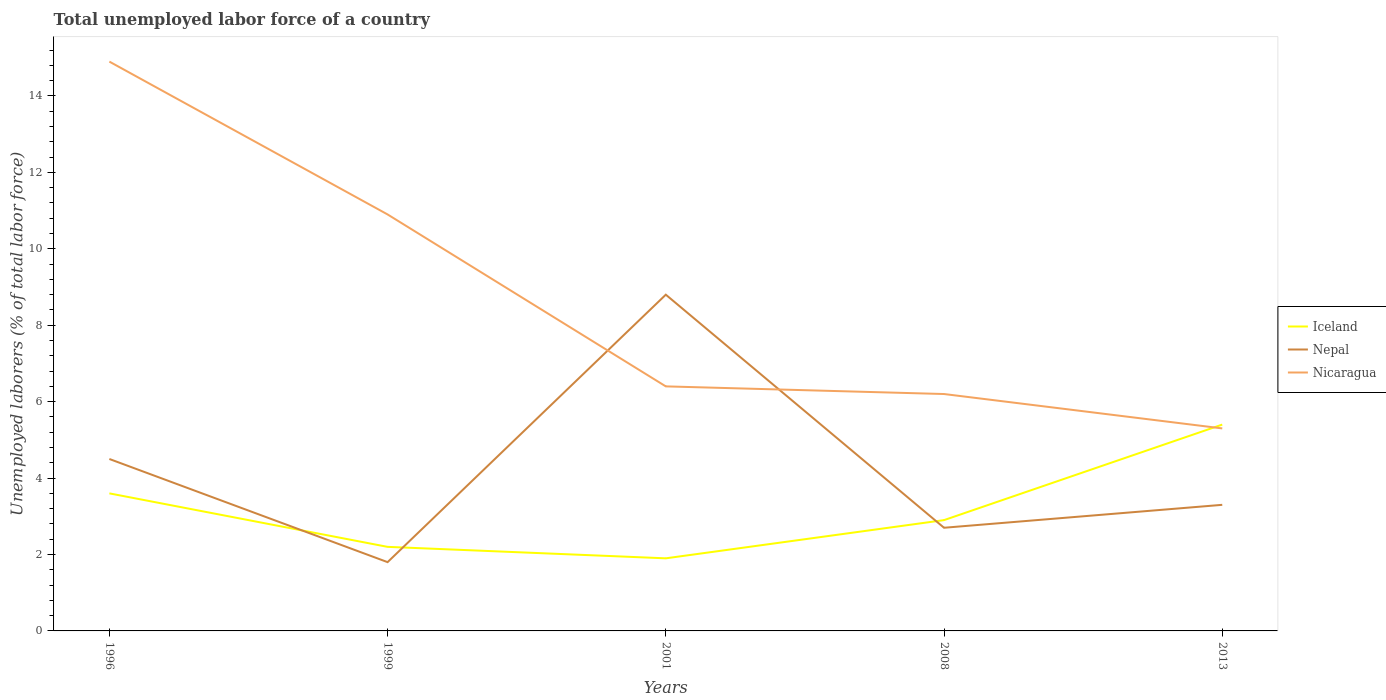How many different coloured lines are there?
Ensure brevity in your answer.  3. Does the line corresponding to Iceland intersect with the line corresponding to Nepal?
Keep it short and to the point. Yes. Is the number of lines equal to the number of legend labels?
Your answer should be compact. Yes. Across all years, what is the maximum total unemployed labor force in Iceland?
Ensure brevity in your answer.  1.9. In which year was the total unemployed labor force in Nicaragua maximum?
Your answer should be very brief. 2013. What is the total total unemployed labor force in Nicaragua in the graph?
Offer a very short reply. 1.1. What is the difference between the highest and the second highest total unemployed labor force in Nicaragua?
Ensure brevity in your answer.  9.6. Is the total unemployed labor force in Nepal strictly greater than the total unemployed labor force in Iceland over the years?
Offer a terse response. No. What is the difference between two consecutive major ticks on the Y-axis?
Your answer should be compact. 2. Where does the legend appear in the graph?
Keep it short and to the point. Center right. What is the title of the graph?
Ensure brevity in your answer.  Total unemployed labor force of a country. What is the label or title of the X-axis?
Your response must be concise. Years. What is the label or title of the Y-axis?
Keep it short and to the point. Unemployed laborers (% of total labor force). What is the Unemployed laborers (% of total labor force) in Iceland in 1996?
Provide a succinct answer. 3.6. What is the Unemployed laborers (% of total labor force) in Nepal in 1996?
Your answer should be compact. 4.5. What is the Unemployed laborers (% of total labor force) of Nicaragua in 1996?
Make the answer very short. 14.9. What is the Unemployed laborers (% of total labor force) in Iceland in 1999?
Your answer should be compact. 2.2. What is the Unemployed laborers (% of total labor force) of Nepal in 1999?
Provide a short and direct response. 1.8. What is the Unemployed laborers (% of total labor force) of Nicaragua in 1999?
Keep it short and to the point. 10.9. What is the Unemployed laborers (% of total labor force) of Iceland in 2001?
Keep it short and to the point. 1.9. What is the Unemployed laborers (% of total labor force) of Nepal in 2001?
Make the answer very short. 8.8. What is the Unemployed laborers (% of total labor force) of Nicaragua in 2001?
Your response must be concise. 6.4. What is the Unemployed laborers (% of total labor force) of Iceland in 2008?
Your response must be concise. 2.9. What is the Unemployed laborers (% of total labor force) in Nepal in 2008?
Make the answer very short. 2.7. What is the Unemployed laborers (% of total labor force) of Nicaragua in 2008?
Your answer should be compact. 6.2. What is the Unemployed laborers (% of total labor force) in Iceland in 2013?
Provide a succinct answer. 5.4. What is the Unemployed laborers (% of total labor force) of Nepal in 2013?
Your response must be concise. 3.3. What is the Unemployed laborers (% of total labor force) of Nicaragua in 2013?
Your answer should be very brief. 5.3. Across all years, what is the maximum Unemployed laborers (% of total labor force) of Iceland?
Provide a succinct answer. 5.4. Across all years, what is the maximum Unemployed laborers (% of total labor force) in Nepal?
Offer a terse response. 8.8. Across all years, what is the maximum Unemployed laborers (% of total labor force) in Nicaragua?
Keep it short and to the point. 14.9. Across all years, what is the minimum Unemployed laborers (% of total labor force) of Iceland?
Provide a short and direct response. 1.9. Across all years, what is the minimum Unemployed laborers (% of total labor force) of Nepal?
Ensure brevity in your answer.  1.8. Across all years, what is the minimum Unemployed laborers (% of total labor force) in Nicaragua?
Provide a succinct answer. 5.3. What is the total Unemployed laborers (% of total labor force) of Nepal in the graph?
Offer a terse response. 21.1. What is the total Unemployed laborers (% of total labor force) in Nicaragua in the graph?
Offer a very short reply. 43.7. What is the difference between the Unemployed laborers (% of total labor force) in Iceland in 1996 and that in 1999?
Your answer should be very brief. 1.4. What is the difference between the Unemployed laborers (% of total labor force) of Nepal in 1996 and that in 1999?
Your answer should be very brief. 2.7. What is the difference between the Unemployed laborers (% of total labor force) in Iceland in 1996 and that in 2001?
Provide a short and direct response. 1.7. What is the difference between the Unemployed laborers (% of total labor force) of Nepal in 1996 and that in 2001?
Give a very brief answer. -4.3. What is the difference between the Unemployed laborers (% of total labor force) in Nicaragua in 1996 and that in 2001?
Your response must be concise. 8.5. What is the difference between the Unemployed laborers (% of total labor force) of Iceland in 1996 and that in 2008?
Your answer should be compact. 0.7. What is the difference between the Unemployed laborers (% of total labor force) in Iceland in 1999 and that in 2001?
Your answer should be very brief. 0.3. What is the difference between the Unemployed laborers (% of total labor force) in Nepal in 1999 and that in 2001?
Offer a terse response. -7. What is the difference between the Unemployed laborers (% of total labor force) in Iceland in 1999 and that in 2008?
Offer a terse response. -0.7. What is the difference between the Unemployed laborers (% of total labor force) in Iceland in 1999 and that in 2013?
Make the answer very short. -3.2. What is the difference between the Unemployed laborers (% of total labor force) in Nepal in 1999 and that in 2013?
Ensure brevity in your answer.  -1.5. What is the difference between the Unemployed laborers (% of total labor force) of Nicaragua in 1999 and that in 2013?
Give a very brief answer. 5.6. What is the difference between the Unemployed laborers (% of total labor force) of Nepal in 2001 and that in 2008?
Your answer should be compact. 6.1. What is the difference between the Unemployed laborers (% of total labor force) in Nicaragua in 2001 and that in 2008?
Give a very brief answer. 0.2. What is the difference between the Unemployed laborers (% of total labor force) of Iceland in 2001 and that in 2013?
Your answer should be compact. -3.5. What is the difference between the Unemployed laborers (% of total labor force) in Iceland in 2008 and that in 2013?
Your response must be concise. -2.5. What is the difference between the Unemployed laborers (% of total labor force) in Iceland in 1996 and the Unemployed laborers (% of total labor force) in Nicaragua in 1999?
Make the answer very short. -7.3. What is the difference between the Unemployed laborers (% of total labor force) in Nepal in 1996 and the Unemployed laborers (% of total labor force) in Nicaragua in 1999?
Make the answer very short. -6.4. What is the difference between the Unemployed laborers (% of total labor force) of Iceland in 1996 and the Unemployed laborers (% of total labor force) of Nepal in 2001?
Ensure brevity in your answer.  -5.2. What is the difference between the Unemployed laborers (% of total labor force) in Nepal in 1996 and the Unemployed laborers (% of total labor force) in Nicaragua in 2001?
Offer a terse response. -1.9. What is the difference between the Unemployed laborers (% of total labor force) of Iceland in 1996 and the Unemployed laborers (% of total labor force) of Nepal in 2013?
Offer a very short reply. 0.3. What is the difference between the Unemployed laborers (% of total labor force) in Nepal in 1999 and the Unemployed laborers (% of total labor force) in Nicaragua in 2001?
Provide a succinct answer. -4.6. What is the difference between the Unemployed laborers (% of total labor force) in Iceland in 1999 and the Unemployed laborers (% of total labor force) in Nepal in 2013?
Offer a very short reply. -1.1. What is the difference between the Unemployed laborers (% of total labor force) in Nepal in 1999 and the Unemployed laborers (% of total labor force) in Nicaragua in 2013?
Make the answer very short. -3.5. What is the difference between the Unemployed laborers (% of total labor force) of Iceland in 2001 and the Unemployed laborers (% of total labor force) of Nepal in 2008?
Ensure brevity in your answer.  -0.8. What is the difference between the Unemployed laborers (% of total labor force) of Iceland in 2001 and the Unemployed laborers (% of total labor force) of Nepal in 2013?
Your response must be concise. -1.4. What is the difference between the Unemployed laborers (% of total labor force) of Iceland in 2001 and the Unemployed laborers (% of total labor force) of Nicaragua in 2013?
Make the answer very short. -3.4. What is the difference between the Unemployed laborers (% of total labor force) in Iceland in 2008 and the Unemployed laborers (% of total labor force) in Nicaragua in 2013?
Provide a succinct answer. -2.4. What is the average Unemployed laborers (% of total labor force) of Nepal per year?
Provide a succinct answer. 4.22. What is the average Unemployed laborers (% of total labor force) in Nicaragua per year?
Keep it short and to the point. 8.74. In the year 1996, what is the difference between the Unemployed laborers (% of total labor force) of Iceland and Unemployed laborers (% of total labor force) of Nepal?
Provide a succinct answer. -0.9. In the year 1996, what is the difference between the Unemployed laborers (% of total labor force) of Nepal and Unemployed laborers (% of total labor force) of Nicaragua?
Keep it short and to the point. -10.4. In the year 1999, what is the difference between the Unemployed laborers (% of total labor force) in Nepal and Unemployed laborers (% of total labor force) in Nicaragua?
Give a very brief answer. -9.1. In the year 2001, what is the difference between the Unemployed laborers (% of total labor force) in Iceland and Unemployed laborers (% of total labor force) in Nepal?
Ensure brevity in your answer.  -6.9. In the year 2001, what is the difference between the Unemployed laborers (% of total labor force) in Iceland and Unemployed laborers (% of total labor force) in Nicaragua?
Offer a very short reply. -4.5. In the year 2001, what is the difference between the Unemployed laborers (% of total labor force) in Nepal and Unemployed laborers (% of total labor force) in Nicaragua?
Give a very brief answer. 2.4. In the year 2008, what is the difference between the Unemployed laborers (% of total labor force) in Iceland and Unemployed laborers (% of total labor force) in Nicaragua?
Make the answer very short. -3.3. In the year 2013, what is the difference between the Unemployed laborers (% of total labor force) of Iceland and Unemployed laborers (% of total labor force) of Nicaragua?
Give a very brief answer. 0.1. In the year 2013, what is the difference between the Unemployed laborers (% of total labor force) in Nepal and Unemployed laborers (% of total labor force) in Nicaragua?
Provide a succinct answer. -2. What is the ratio of the Unemployed laborers (% of total labor force) in Iceland in 1996 to that in 1999?
Provide a succinct answer. 1.64. What is the ratio of the Unemployed laborers (% of total labor force) in Nepal in 1996 to that in 1999?
Give a very brief answer. 2.5. What is the ratio of the Unemployed laborers (% of total labor force) in Nicaragua in 1996 to that in 1999?
Your response must be concise. 1.37. What is the ratio of the Unemployed laborers (% of total labor force) of Iceland in 1996 to that in 2001?
Your response must be concise. 1.89. What is the ratio of the Unemployed laborers (% of total labor force) of Nepal in 1996 to that in 2001?
Offer a terse response. 0.51. What is the ratio of the Unemployed laborers (% of total labor force) in Nicaragua in 1996 to that in 2001?
Your response must be concise. 2.33. What is the ratio of the Unemployed laborers (% of total labor force) in Iceland in 1996 to that in 2008?
Keep it short and to the point. 1.24. What is the ratio of the Unemployed laborers (% of total labor force) in Nicaragua in 1996 to that in 2008?
Keep it short and to the point. 2.4. What is the ratio of the Unemployed laborers (% of total labor force) of Nepal in 1996 to that in 2013?
Ensure brevity in your answer.  1.36. What is the ratio of the Unemployed laborers (% of total labor force) of Nicaragua in 1996 to that in 2013?
Give a very brief answer. 2.81. What is the ratio of the Unemployed laborers (% of total labor force) of Iceland in 1999 to that in 2001?
Make the answer very short. 1.16. What is the ratio of the Unemployed laborers (% of total labor force) of Nepal in 1999 to that in 2001?
Offer a terse response. 0.2. What is the ratio of the Unemployed laborers (% of total labor force) of Nicaragua in 1999 to that in 2001?
Ensure brevity in your answer.  1.7. What is the ratio of the Unemployed laborers (% of total labor force) in Iceland in 1999 to that in 2008?
Offer a very short reply. 0.76. What is the ratio of the Unemployed laborers (% of total labor force) of Nepal in 1999 to that in 2008?
Offer a very short reply. 0.67. What is the ratio of the Unemployed laborers (% of total labor force) in Nicaragua in 1999 to that in 2008?
Your response must be concise. 1.76. What is the ratio of the Unemployed laborers (% of total labor force) in Iceland in 1999 to that in 2013?
Your answer should be very brief. 0.41. What is the ratio of the Unemployed laborers (% of total labor force) of Nepal in 1999 to that in 2013?
Provide a succinct answer. 0.55. What is the ratio of the Unemployed laborers (% of total labor force) of Nicaragua in 1999 to that in 2013?
Give a very brief answer. 2.06. What is the ratio of the Unemployed laborers (% of total labor force) of Iceland in 2001 to that in 2008?
Offer a terse response. 0.66. What is the ratio of the Unemployed laborers (% of total labor force) of Nepal in 2001 to that in 2008?
Give a very brief answer. 3.26. What is the ratio of the Unemployed laborers (% of total labor force) of Nicaragua in 2001 to that in 2008?
Your answer should be compact. 1.03. What is the ratio of the Unemployed laborers (% of total labor force) in Iceland in 2001 to that in 2013?
Your answer should be very brief. 0.35. What is the ratio of the Unemployed laborers (% of total labor force) in Nepal in 2001 to that in 2013?
Your response must be concise. 2.67. What is the ratio of the Unemployed laborers (% of total labor force) in Nicaragua in 2001 to that in 2013?
Offer a very short reply. 1.21. What is the ratio of the Unemployed laborers (% of total labor force) in Iceland in 2008 to that in 2013?
Provide a short and direct response. 0.54. What is the ratio of the Unemployed laborers (% of total labor force) in Nepal in 2008 to that in 2013?
Ensure brevity in your answer.  0.82. What is the ratio of the Unemployed laborers (% of total labor force) in Nicaragua in 2008 to that in 2013?
Provide a succinct answer. 1.17. What is the difference between the highest and the lowest Unemployed laborers (% of total labor force) of Iceland?
Ensure brevity in your answer.  3.5. What is the difference between the highest and the lowest Unemployed laborers (% of total labor force) in Nepal?
Offer a terse response. 7. 